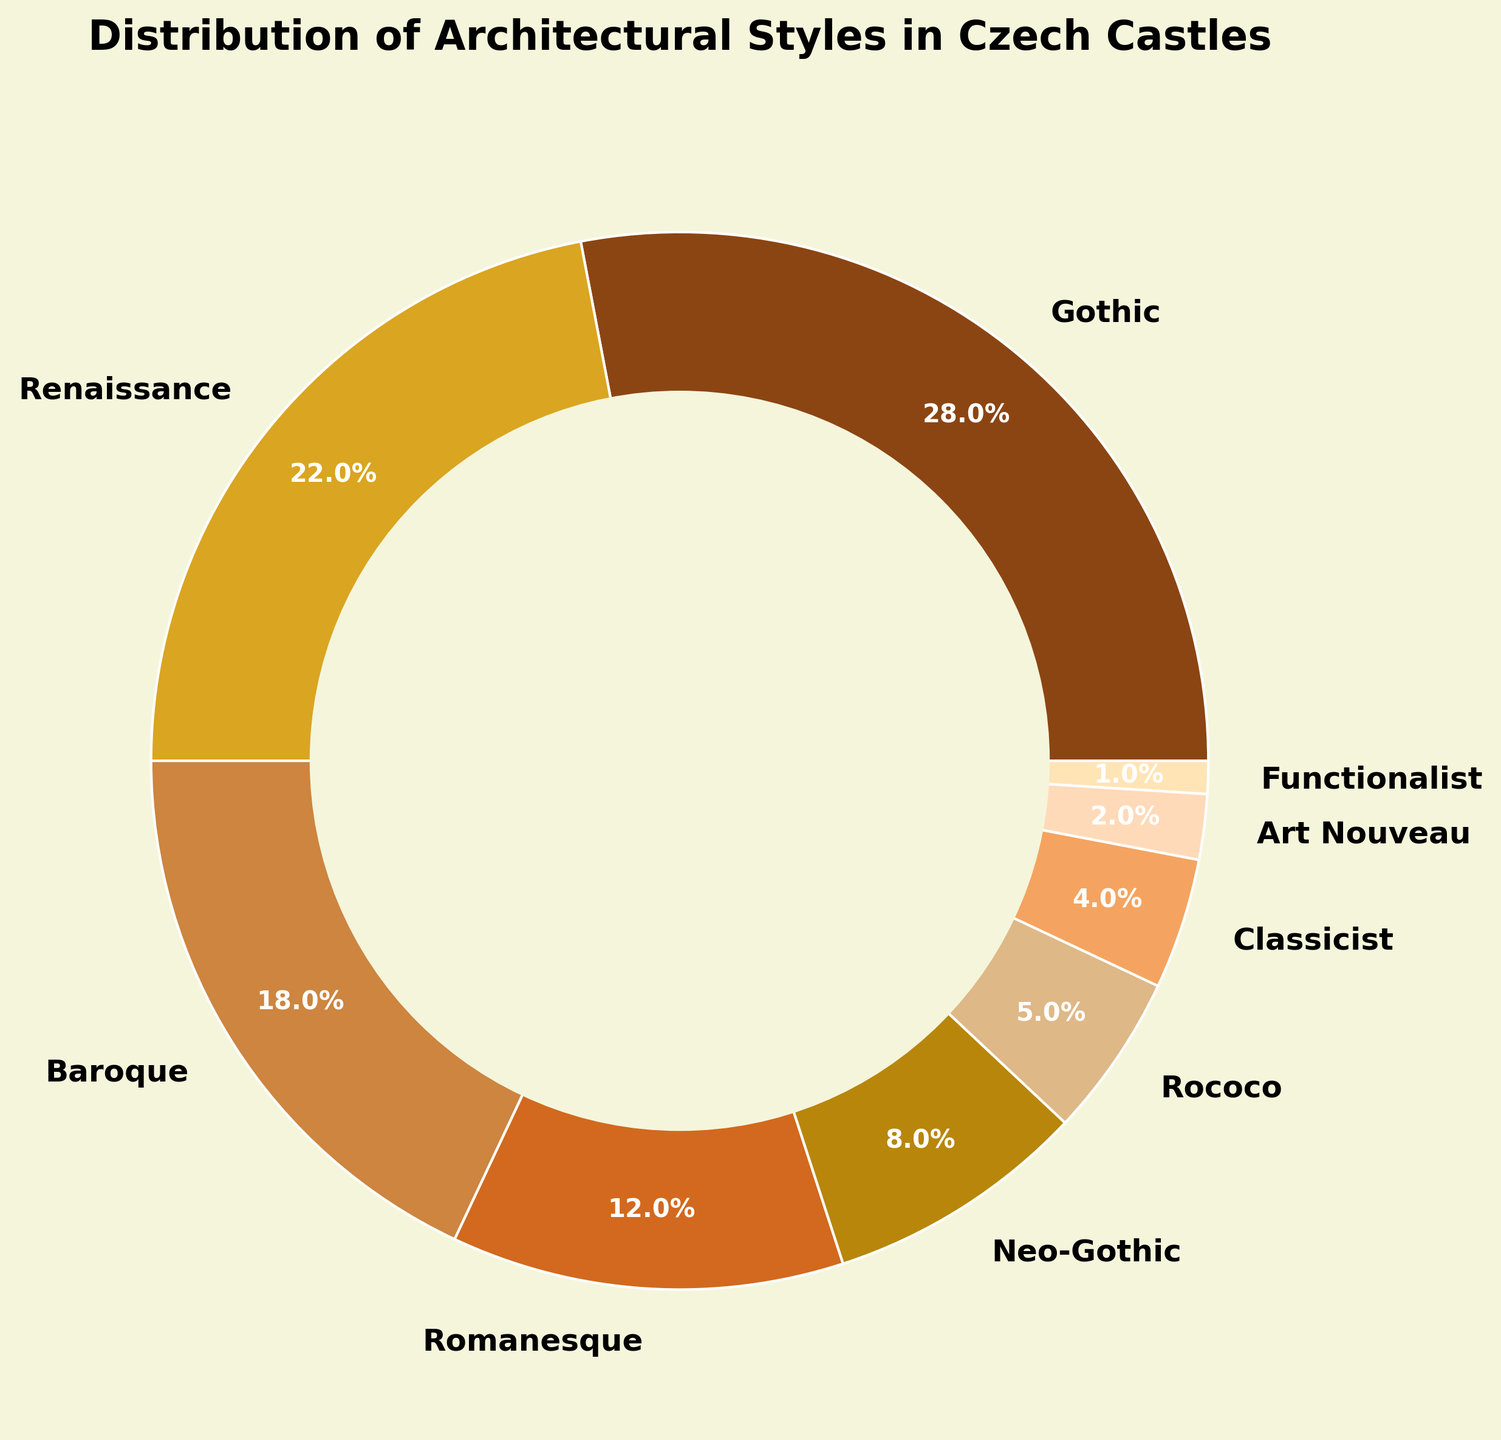what percentage of Czech castles are of Gothic and Renaissance styles combined? First, identify the percentage of Gothic style castles (28%) and the percentage for Renaissance style castles (22%). Then, add these two percentages together: 28% + 22% = 50%. Therefore, the combined percentage is 50%.
Answer: 50% Which architectural style is the least represented among Czech castles? Determine the architectural style with the smallest percentage. From the data, the Functionalist style has the lowest percentage at 1%.
Answer: Functionalist Is the percentage of Neo-Gothic style castles more than or less than half of the percentage of Baroque castles? First, identify the percentage of Neo-Gothic style castles (8%) and Baroque style castles (18%). Calculate half of the Baroque percentage: 18% / 2 = 9%. Compare the values: 8% (Neo-Gothic) is less than 9% (half of Baroque).
Answer: Less than How much greater is the percentage of Gothic style castles compared to Classicist style castles? Find the percentage for Gothic (28%) and Classicist (4%). Subtract the Classicist percentage from the Gothic percentage: 28% - 4% = 24%. Therefore, Gothic is 24 percentage points greater than Classicist.
Answer: 24% Which three architectural styles have the highest representation in Czech castles? Identify the three architectural styles with the highest percentages: Gothic (28%), Renaissance (22%), and Baroque (18%).
Answer: Gothic, Renaissance, Baroque What is the combined percentage of castles that are Neo-Gothic, Romanesque, and Art Nouveau styles? Identify the percentages: Neo-Gothic (8%), Romanesque (12%), and Art Nouveau (2%). Add these together: 8% + 12% + 2% = 22%. Therefore, the combined percentage is 22%.
Answer: 22% If Baroque and Rococo styles are combined, would their total percentage surpass the Gothic style? First, find the percentages for Baroque (18%) and Rococo (5%). Add these together: 18% + 5% = 23%. Compare this value with the Gothic style percentage (28%). Since 23% is less than 28%, their combined percentage does not surpass Gothic.
Answer: No What is the visual color representation of the Renaissance style in the pie chart? Identify the specific color used for Renaissance style in the pie chart. According to the color scheme, Renaissance is represented by a golden color.
Answer: Golden Which style has a higher percentage: Rococo or Classicist? Identify the percentages for Rococo (5%) and Classicist (4%). Compare the two values: 5% (Rococo) is higher than 4% (Classicist).
Answer: Rococo What is the combined percentage of the three least represented architectural styles? Identify the three architectural styles with the lowest percentages: Art Nouveau (2%), Functionalist (1%), and Classicist (4%). Add these together: 2% + 1% + 4% = 7%.
Answer: 7% 